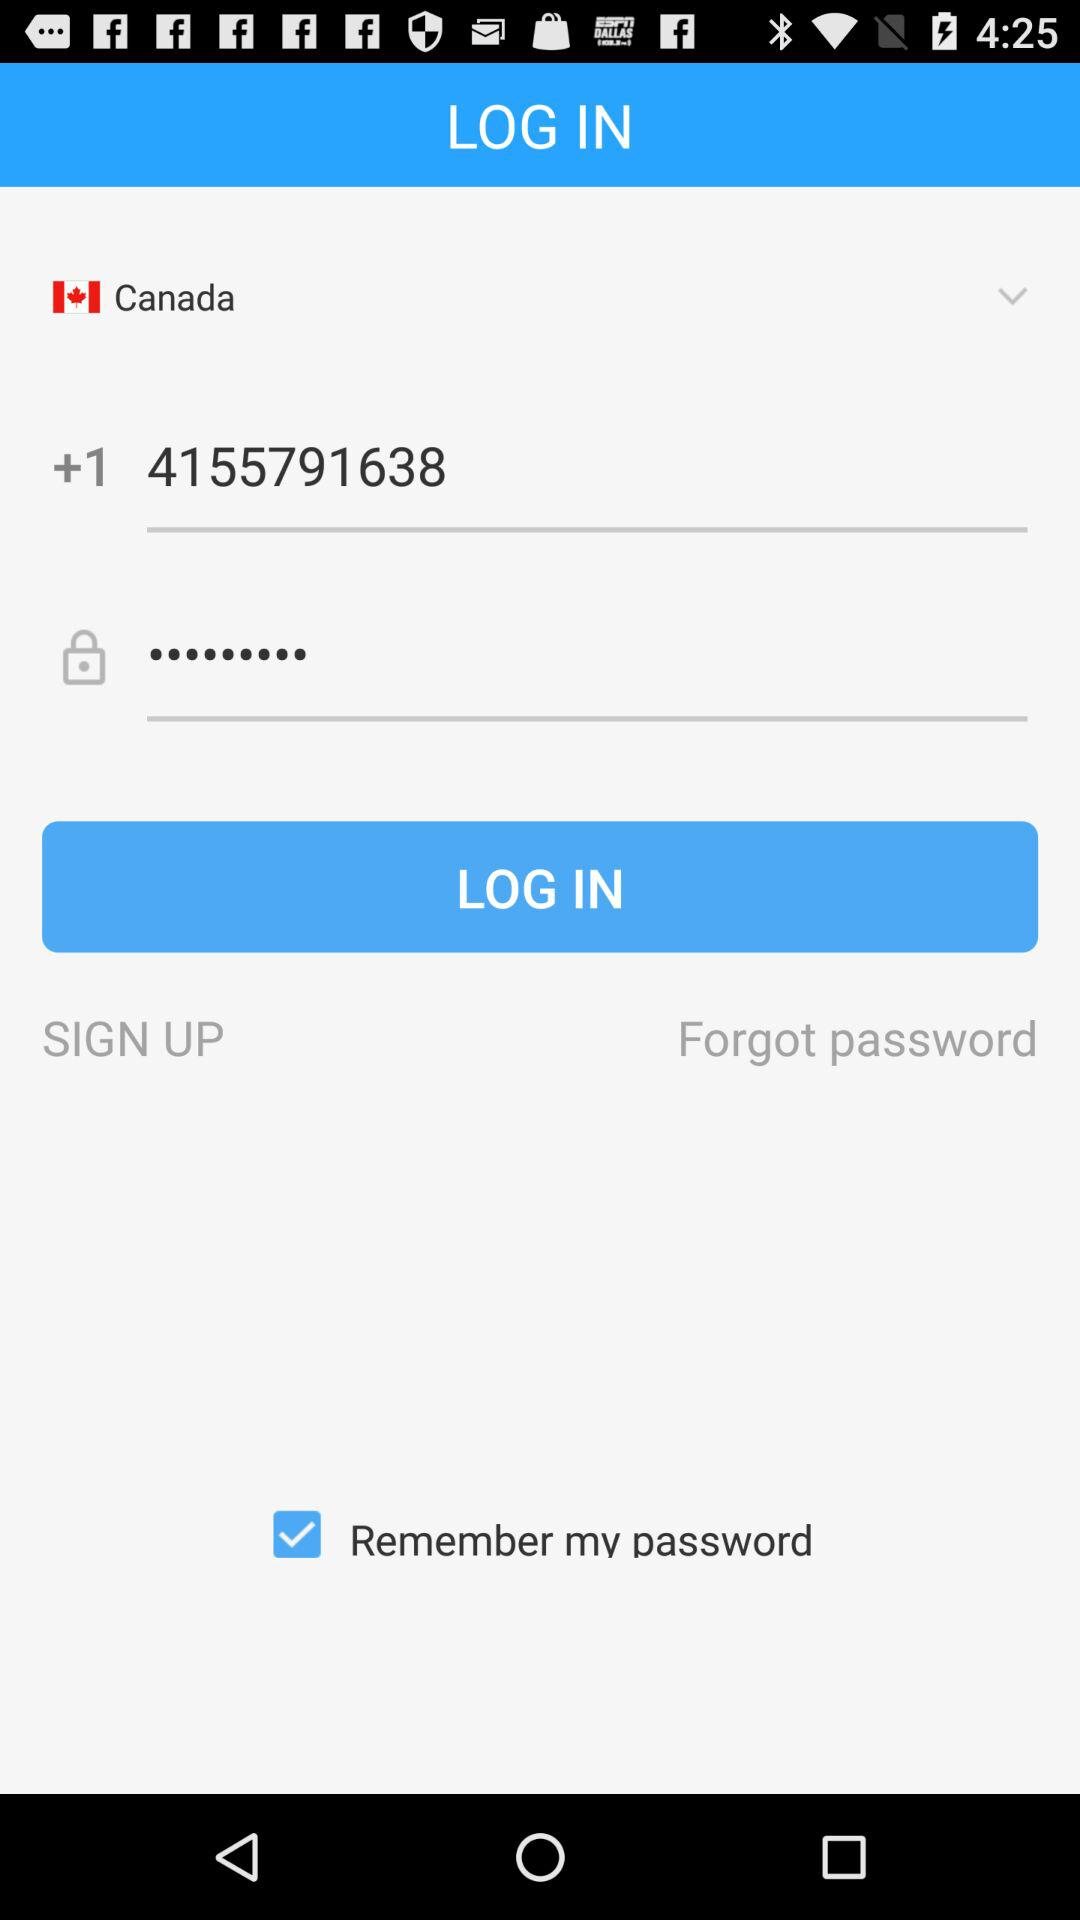What is the phone number? The phone number is +14155791638. 